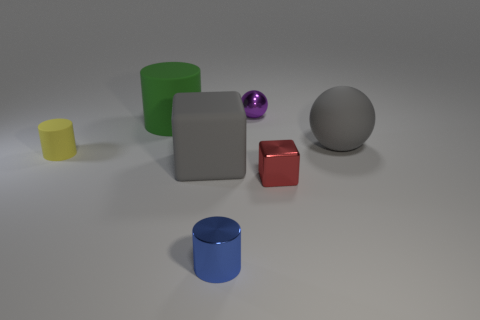Add 3 blue metal things. How many objects exist? 10 Subtract all spheres. How many objects are left? 5 Add 4 purple things. How many purple things are left? 5 Add 6 small yellow matte objects. How many small yellow matte objects exist? 7 Subtract 0 brown blocks. How many objects are left? 7 Subtract all big spheres. Subtract all metal blocks. How many objects are left? 5 